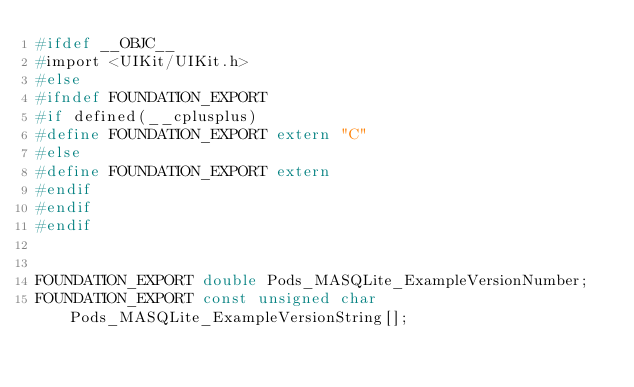Convert code to text. <code><loc_0><loc_0><loc_500><loc_500><_C_>#ifdef __OBJC__
#import <UIKit/UIKit.h>
#else
#ifndef FOUNDATION_EXPORT
#if defined(__cplusplus)
#define FOUNDATION_EXPORT extern "C"
#else
#define FOUNDATION_EXPORT extern
#endif
#endif
#endif


FOUNDATION_EXPORT double Pods_MASQLite_ExampleVersionNumber;
FOUNDATION_EXPORT const unsigned char Pods_MASQLite_ExampleVersionString[];

</code> 